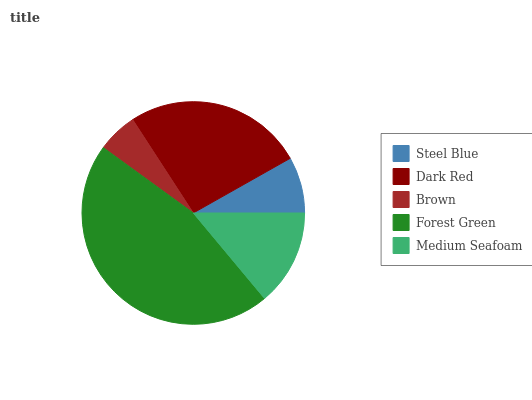Is Brown the minimum?
Answer yes or no. Yes. Is Forest Green the maximum?
Answer yes or no. Yes. Is Dark Red the minimum?
Answer yes or no. No. Is Dark Red the maximum?
Answer yes or no. No. Is Dark Red greater than Steel Blue?
Answer yes or no. Yes. Is Steel Blue less than Dark Red?
Answer yes or no. Yes. Is Steel Blue greater than Dark Red?
Answer yes or no. No. Is Dark Red less than Steel Blue?
Answer yes or no. No. Is Medium Seafoam the high median?
Answer yes or no. Yes. Is Medium Seafoam the low median?
Answer yes or no. Yes. Is Brown the high median?
Answer yes or no. No. Is Steel Blue the low median?
Answer yes or no. No. 